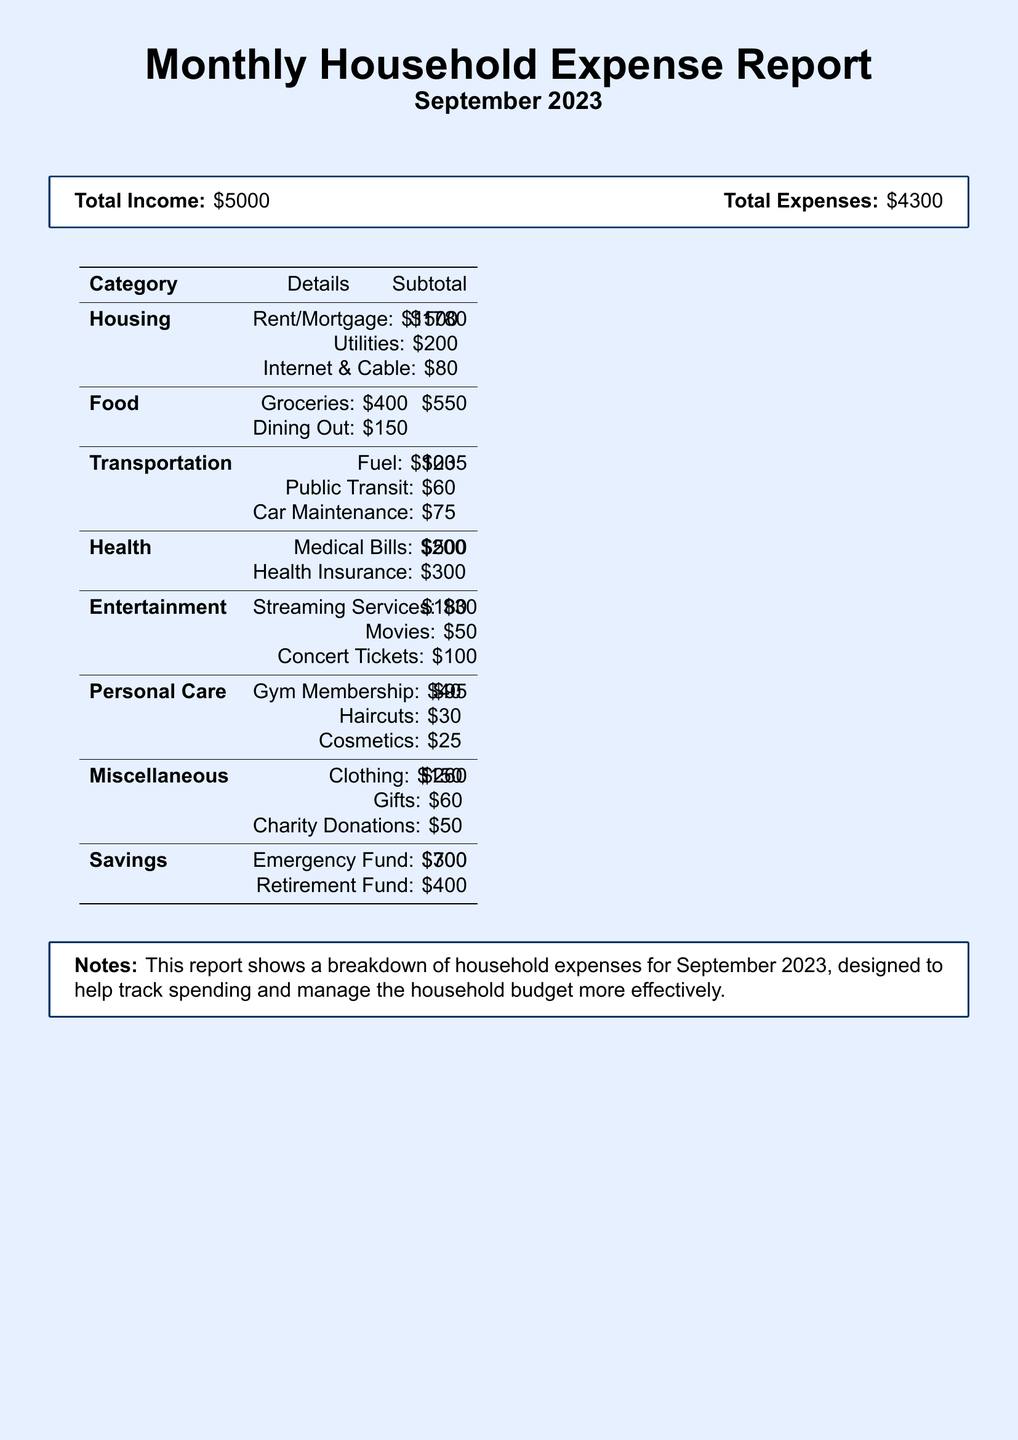What is the total income? The total income is provided at the beginning of the document, which is $5000.
Answer: $5000 What is the total expense amount? The total expenses are listed in the report, which amounts to $4300.
Answer: $4300 How much was spent on housing? The subtotal for the housing category is broken down in the table, totaling $1780.
Answer: $1780 What is the spending amount for groceries? The groceries expense is listed separately under the food category, which is $400.
Answer: $400 Which category has the lowest expense? By comparing the subtotals, the personal care category has the lowest expense of $95.
Answer: $95 What are the two main types of savings listed? The report specifies two savings types: emergency fund and retirement fund with amounts shown.
Answer: Emergency Fund and Retirement Fund What is the total amount spent on health-related expenses? The health category expenses total to $500, which includes medical bills and health insurance.
Answer: $500 Which category includes the highest amount for entertainment? The entertainment category includes concert tickets, which is the highest expense listed at $100.
Answer: Concert Tickets What is the purpose of this report? The notes section states that the report is designed to help track spending and manage the household budget.
Answer: Track spending and manage budget 